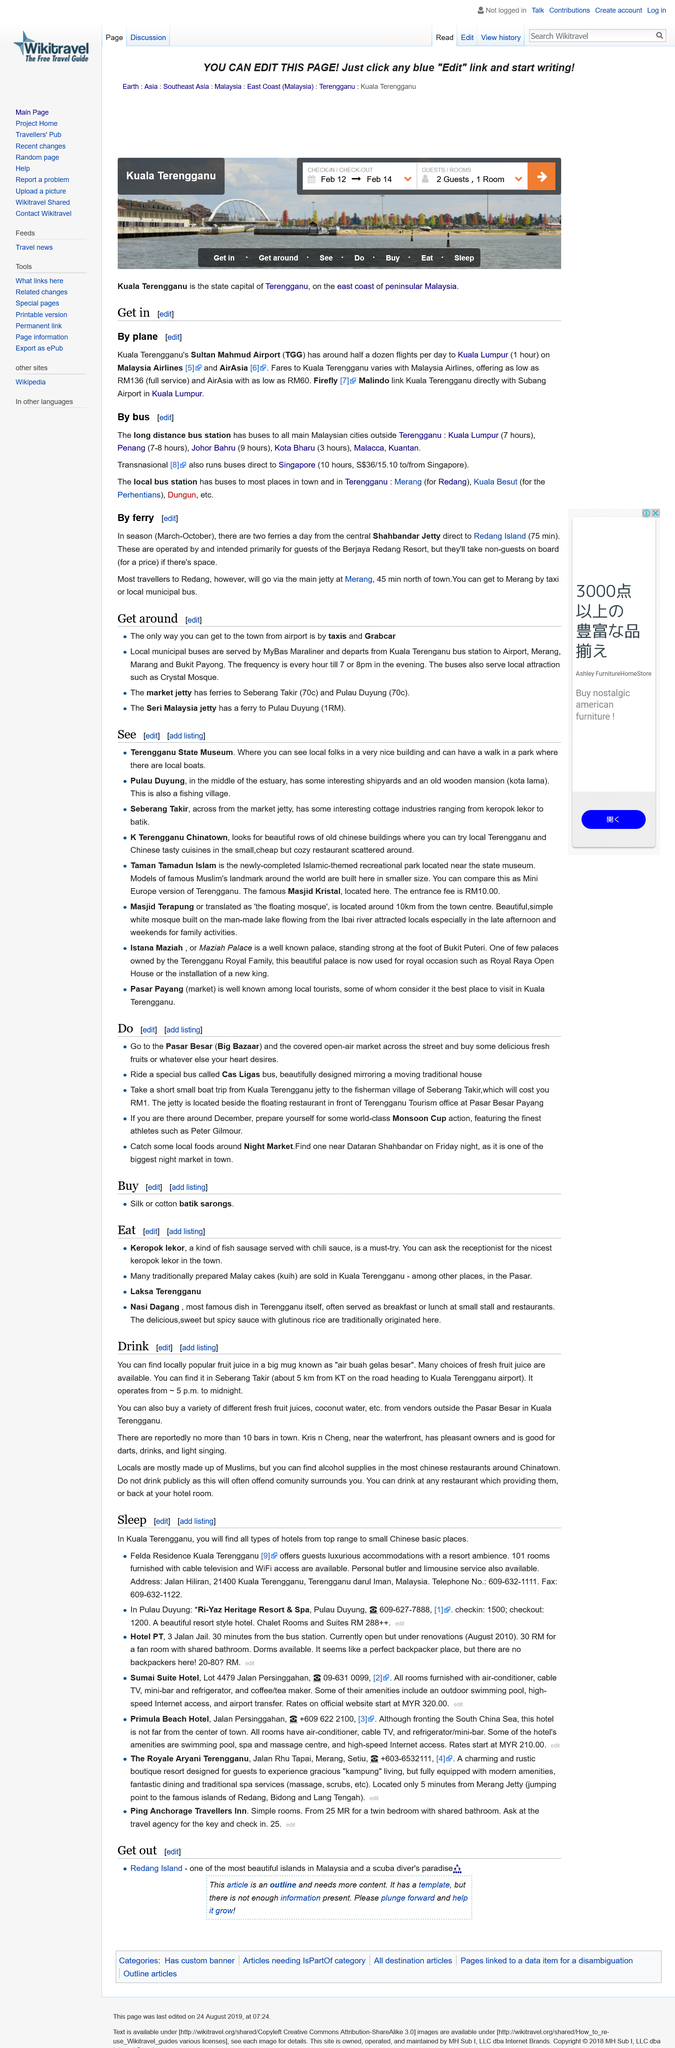Outline some significant characteristics in this image. There are no more than 10 bars in town, and I have counted them all. The state capital of Terengganu is Kuala Terengganu. Seberang Takir operates from 5:00 PM to 12:00 AM. Kuala Terengganu is located on the east coast of peninsular Malaysia, and can be identified as a prominent location. The popular fruit juice served in a large mug is known as air buah gelas besar. 